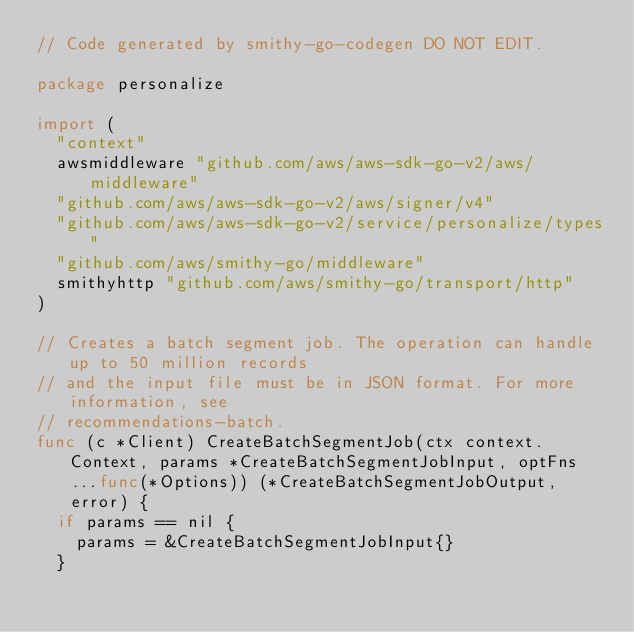<code> <loc_0><loc_0><loc_500><loc_500><_Go_>// Code generated by smithy-go-codegen DO NOT EDIT.

package personalize

import (
	"context"
	awsmiddleware "github.com/aws/aws-sdk-go-v2/aws/middleware"
	"github.com/aws/aws-sdk-go-v2/aws/signer/v4"
	"github.com/aws/aws-sdk-go-v2/service/personalize/types"
	"github.com/aws/smithy-go/middleware"
	smithyhttp "github.com/aws/smithy-go/transport/http"
)

// Creates a batch segment job. The operation can handle up to 50 million records
// and the input file must be in JSON format. For more information, see
// recommendations-batch.
func (c *Client) CreateBatchSegmentJob(ctx context.Context, params *CreateBatchSegmentJobInput, optFns ...func(*Options)) (*CreateBatchSegmentJobOutput, error) {
	if params == nil {
		params = &CreateBatchSegmentJobInput{}
	}
</code> 